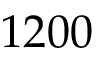<formula> <loc_0><loc_0><loc_500><loc_500>1 2 0 0</formula> 